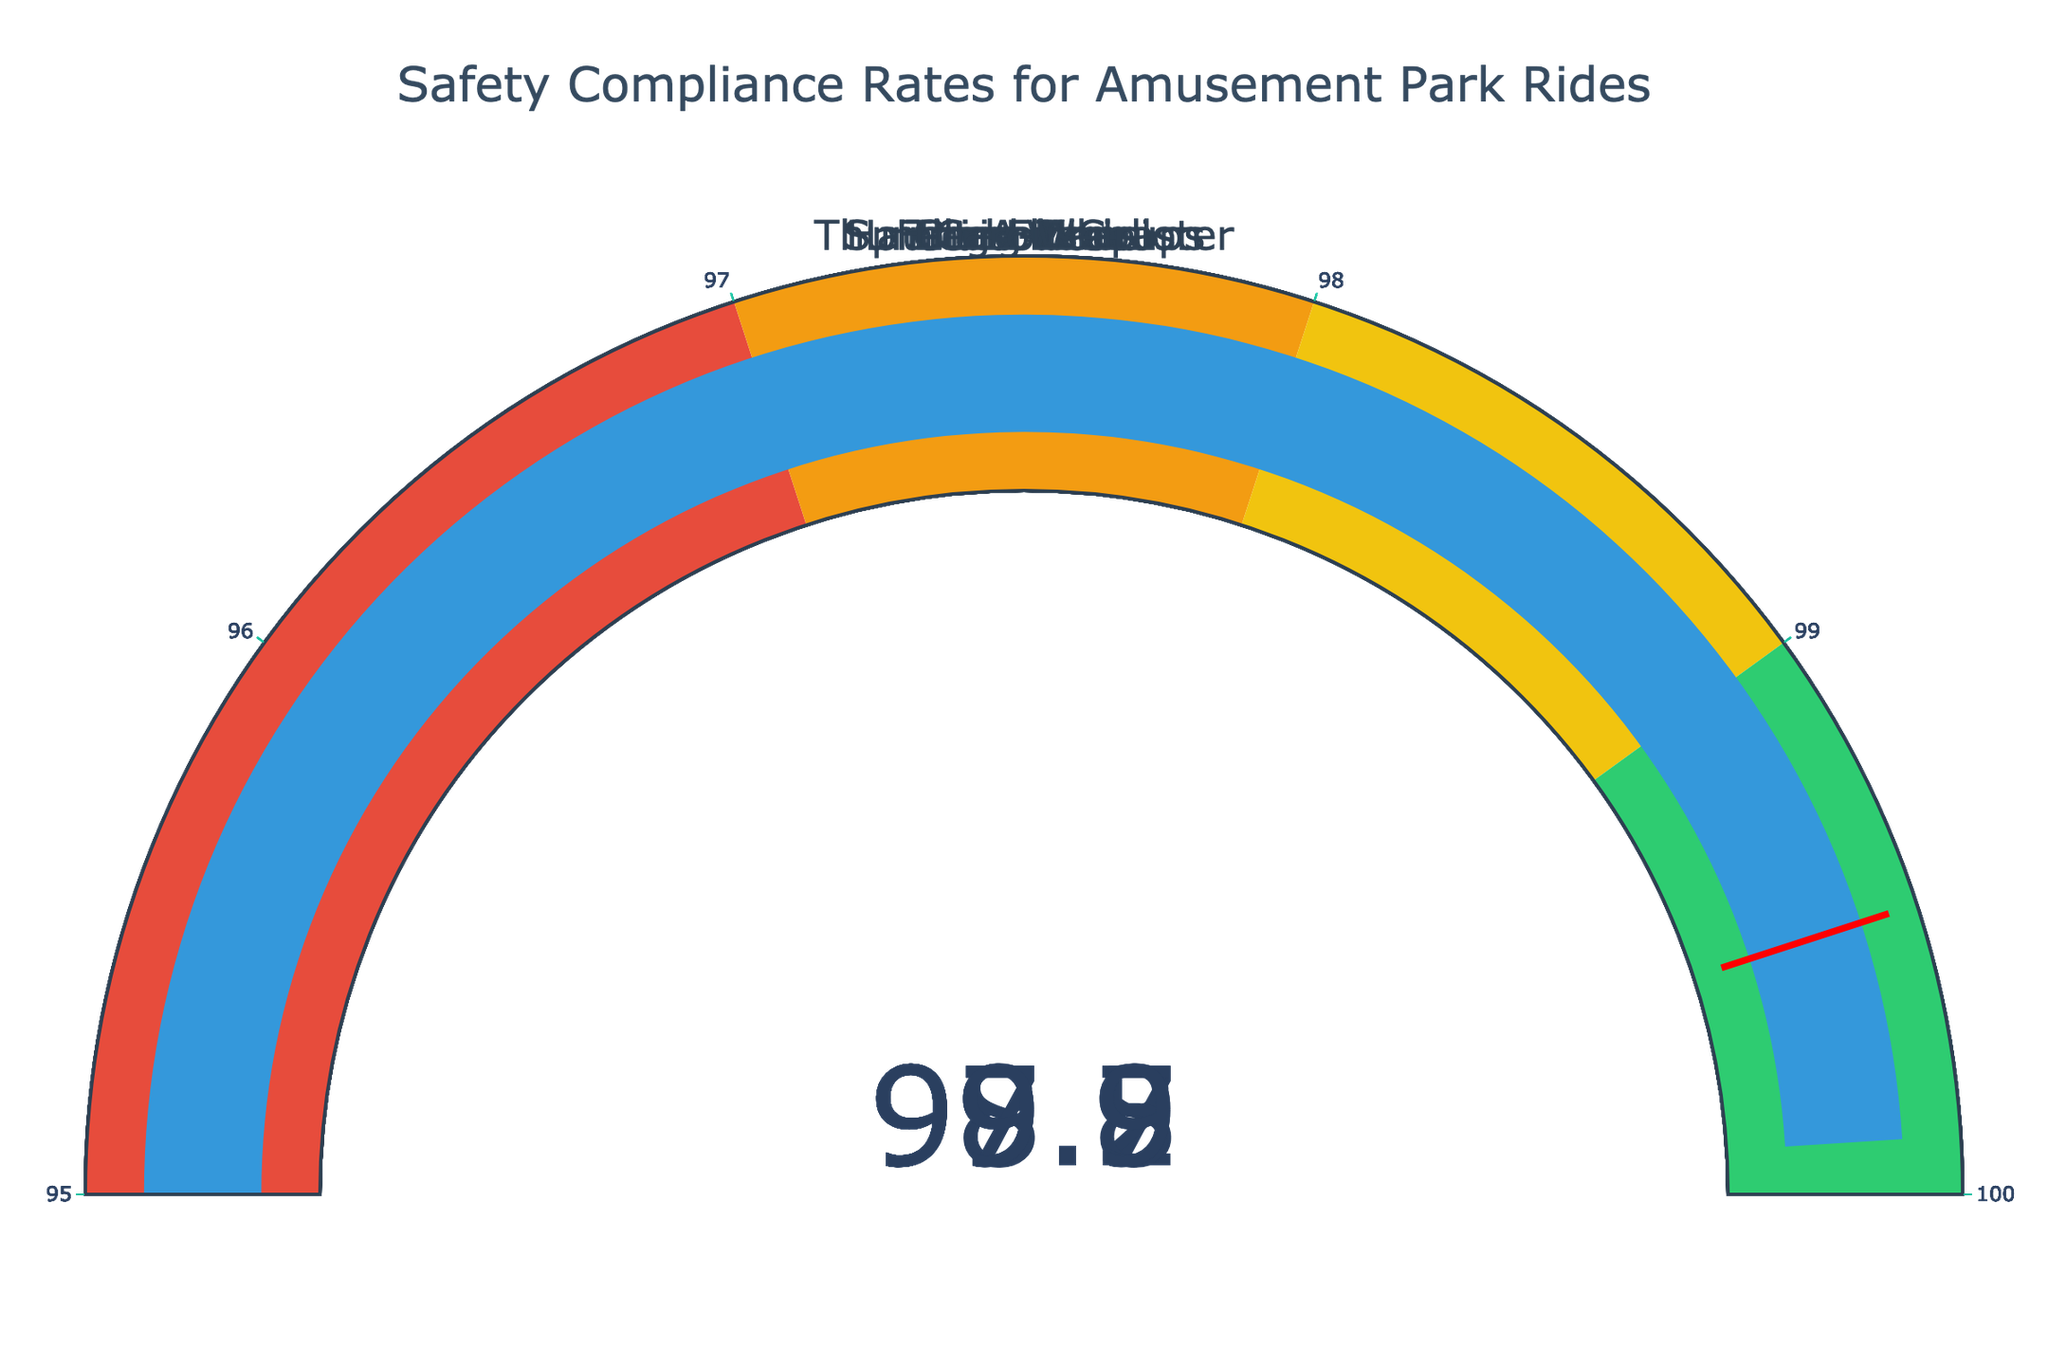What's the Safety Compliance Rate of the Carousel? The figure shows the Safety Compliance Rates for various amusement park rides. To find the rate for the Carousel, locate its gauge and read the number.
Answer: 99.9 Which ride has the highest Safety Compliance Rate? By inspecting the gauge indicators, identify the ride with the highest number displayed. The Carousel shows the highest rate at 99.9.
Answer: Carousel What's the difference in Safety Compliance Rate between the Spinning Teacups and the Haunted Mansion? To find the difference, subtract the compliance rate of the Spinning Teacups (97.5) from the Haunted Mansion (99.8). Computation: 99.8 - 97.5 = 2.3.
Answer: 2.3 Is the Safety Compliance Rate of the Giant Drop greater than 99? Find the compliance rate of the Giant Drop on its gauge indicator. It shows 98.7, which is not greater than 99.
Answer: No How many rides have a Safety Compliance Rate less than the threshold value of 99.5? Examine the gauges and count the number of rides with rates below 99.5. These are Giant Drop, Spinning Teacups, Log Flume, and Tilt-A-Whirl, which totals to 4.
Answer: 4 What's the average Safety Compliance Rate for all the rides? Sum all compliance rates (98.7 + 99.2 + 97.5 + 99.8 + 98.3 + 99.5 + 97.9 + 99.9) and divide by the number of rides (8). Computation: (98.7 + 99.2 + 97.5 + 99.8 + 98.3 + 99.5 + 97.9 + 99.9) / 8 = 98.85.
Answer: 98.85 Which ride has the lowest Safety Compliance Rate? By examining the gauge indicators, the Spinning Teacups has the lowest rate at 97.5.
Answer: Spinning Teacups Do any rides have a Safety Compliance Rate exactly matching the threshold of 99.5? Check the gauge indicators to see if any ride has the rate of 99.5. The Ferris Wheel matches this rate exactly.
Answer: Yes, the Ferris Wheel What's the Safety Compliance Rate range covered by the steps on the gauges? The steps on the gauges cover ranges from 95 to 97 (red), 97 to 98 (orange), 98 to 99 (yellow), and 99 to 100 (green).
Answer: 95-100 